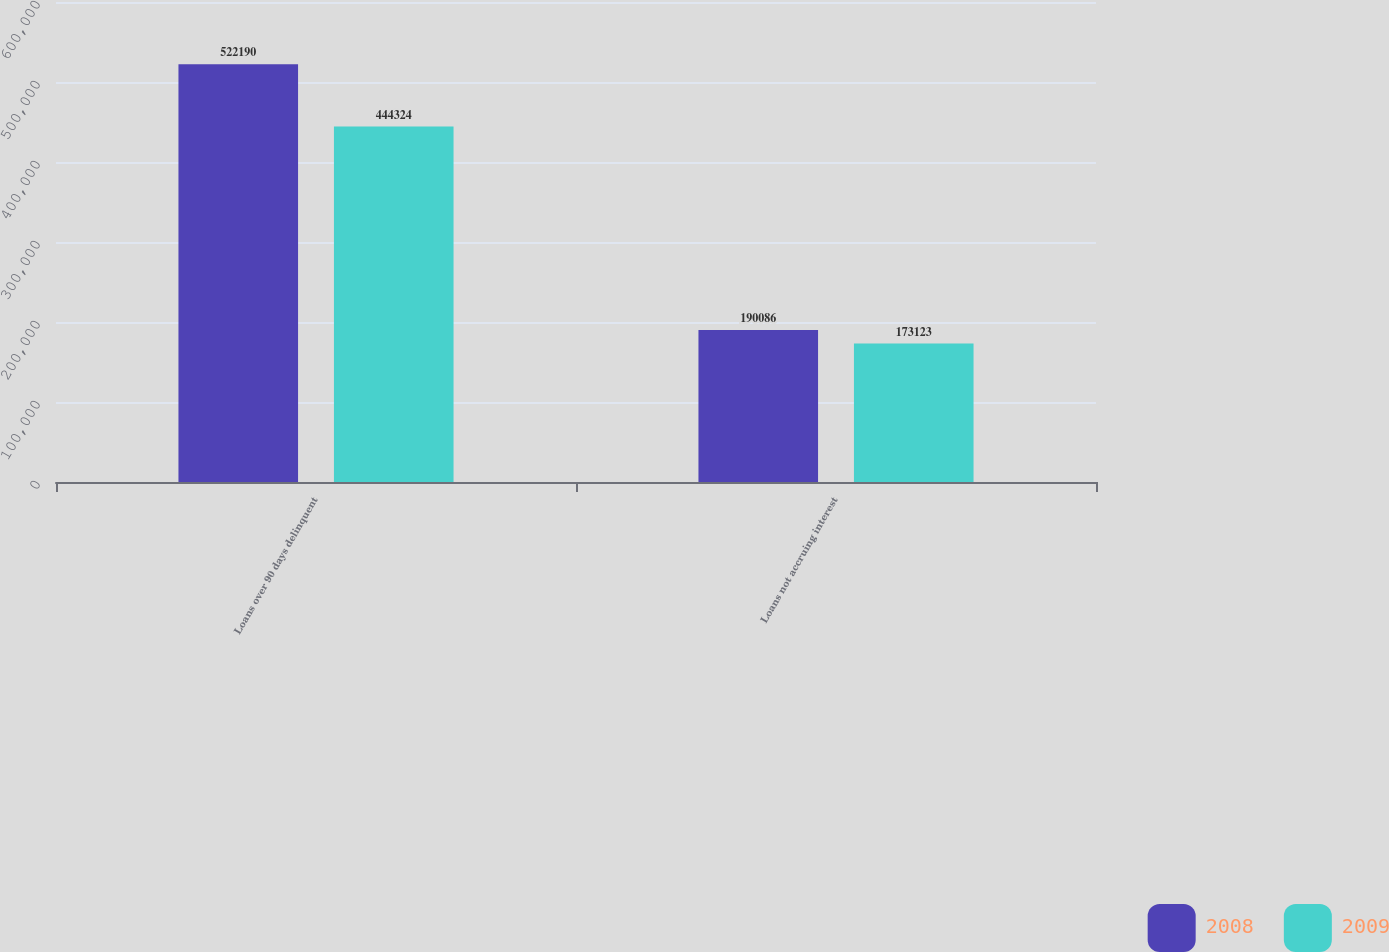Convert chart. <chart><loc_0><loc_0><loc_500><loc_500><stacked_bar_chart><ecel><fcel>Loans over 90 days delinquent<fcel>Loans not accruing interest<nl><fcel>2008<fcel>522190<fcel>190086<nl><fcel>2009<fcel>444324<fcel>173123<nl></chart> 